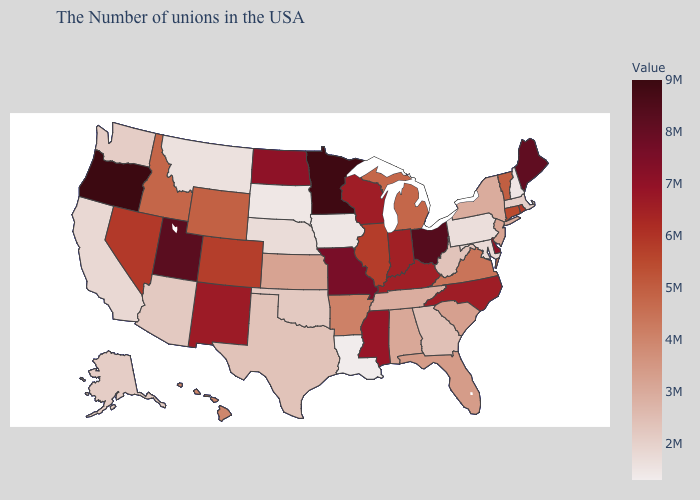Is the legend a continuous bar?
Be succinct. Yes. Does Texas have a higher value than New Hampshire?
Give a very brief answer. Yes. Which states have the highest value in the USA?
Concise answer only. Oregon. Which states have the highest value in the USA?
Concise answer only. Oregon. Does Louisiana have the lowest value in the USA?
Give a very brief answer. Yes. Does Washington have the lowest value in the USA?
Concise answer only. No. 